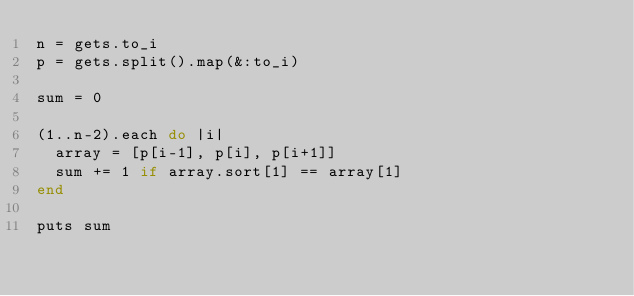Convert code to text. <code><loc_0><loc_0><loc_500><loc_500><_Ruby_>n = gets.to_i
p = gets.split().map(&:to_i)

sum = 0

(1..n-2).each do |i|
  array = [p[i-1], p[i], p[i+1]]
  sum += 1 if array.sort[1] == array[1]
end

puts sum</code> 